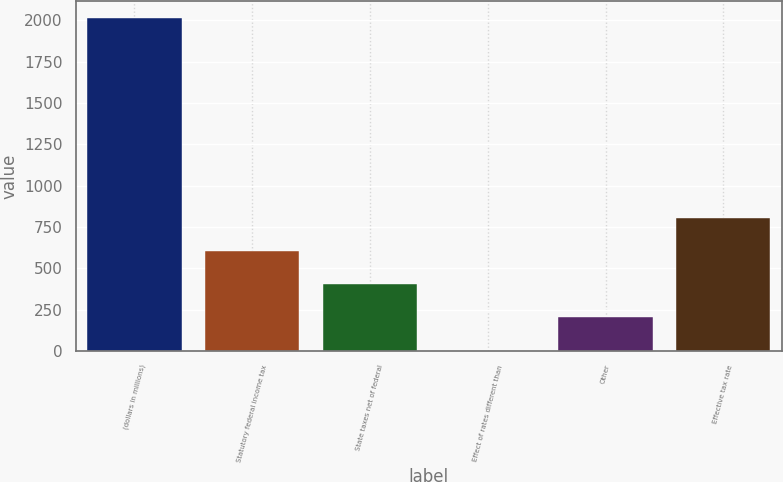Convert chart to OTSL. <chart><loc_0><loc_0><loc_500><loc_500><bar_chart><fcel>(dollars in millions)<fcel>Statutory federal income tax<fcel>State taxes net of federal<fcel>Effect of rates different than<fcel>Other<fcel>Effective tax rate<nl><fcel>2014<fcel>605.53<fcel>404.32<fcel>1.9<fcel>203.11<fcel>806.74<nl></chart> 